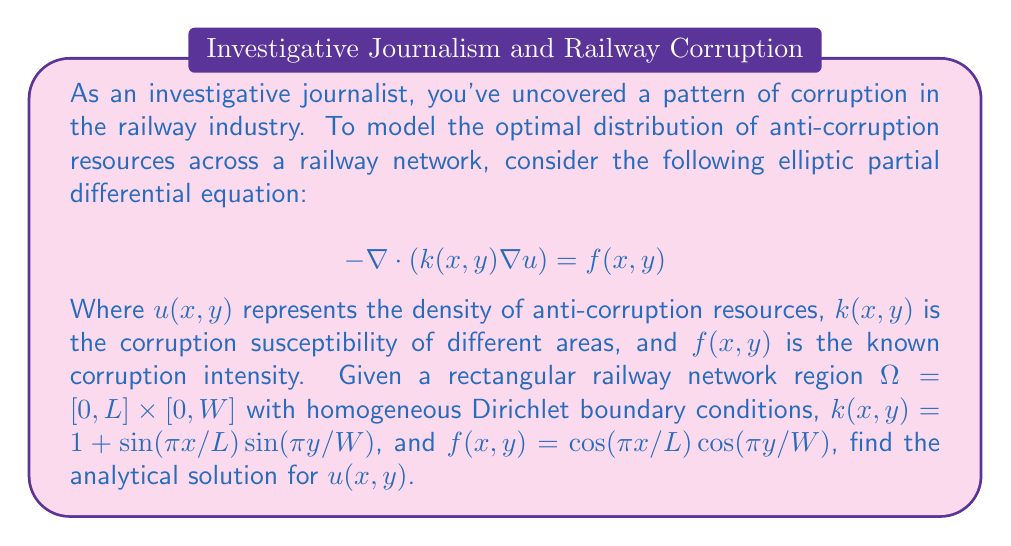Can you answer this question? To solve this elliptic PDE, we'll use the method of separation of variables:

1) Assume the solution has the form: $u(x,y) = X(x)Y(y)$

2) Substitute this into the PDE:
   $$-\nabla \cdot ((1 + \sin(\pi x/L)\sin(\pi y/W)) \nabla (X(x)Y(y))) = \cos(\pi x/L)\cos(\pi y/W)$$

3) Expand the left-hand side:
   $$-(1 + \sin(\pi x/L)\sin(\pi y/W))(X''(x)Y(y) + X(x)Y''(y)) - (\frac{\pi}{L}\cos(\pi x/L)\sin(\pi y/W)X'(x)Y(y) + \frac{\pi}{W}\sin(\pi x/L)\cos(\pi y/W)X(x)Y'(y)) = \cos(\pi x/L)\cos(\pi y/W)$$

4) This equation is difficult to separate directly. However, given the form of $k(x,y)$ and $f(x,y)$, we can guess a solution of the form:
   $$u(x,y) = A \cos(\pi x/L)\cos(\pi y/W)$$

5) Substitute this guess into the original PDE:
   $$-\nabla \cdot ((1 + \sin(\pi x/L)\sin(\pi y/W)) \nabla (A \cos(\pi x/L)\cos(\pi y/W))) = \cos(\pi x/L)\cos(\pi y/W)$$

6) Expand the left-hand side:
   $$A(\frac{\pi^2}{L^2} + \frac{\pi^2}{W^2})(1 + \sin(\pi x/L)\sin(\pi y/W))\cos(\pi x/L)\cos(\pi y/W) = \cos(\pi x/L)\cos(\pi y/W)$$

7) For this to be true for all $x$ and $y$, we must have:
   $$A(\frac{\pi^2}{L^2} + \frac{\pi^2}{W^2}) = 1$$

8) Solve for $A$:
   $$A = \frac{1}{\frac{\pi^2}{L^2} + \frac{\pi^2}{W^2}} = \frac{L^2W^2}{\pi^2(L^2 + W^2)}$$

9) Therefore, the analytical solution is:
   $$u(x,y) = \frac{L^2W^2}{\pi^2(L^2 + W^2)} \cos(\pi x/L)\cos(\pi y/W)$$

This solution satisfies the homogeneous Dirichlet boundary conditions as $\cos(\pi x/L) = 0$ when $x = 0$ or $x = L$, and $\cos(\pi y/W) = 0$ when $y = 0$ or $y = W$.
Answer: $$u(x,y) = \frac{L^2W^2}{\pi^2(L^2 + W^2)} \cos(\pi x/L)\cos(\pi y/W)$$ 